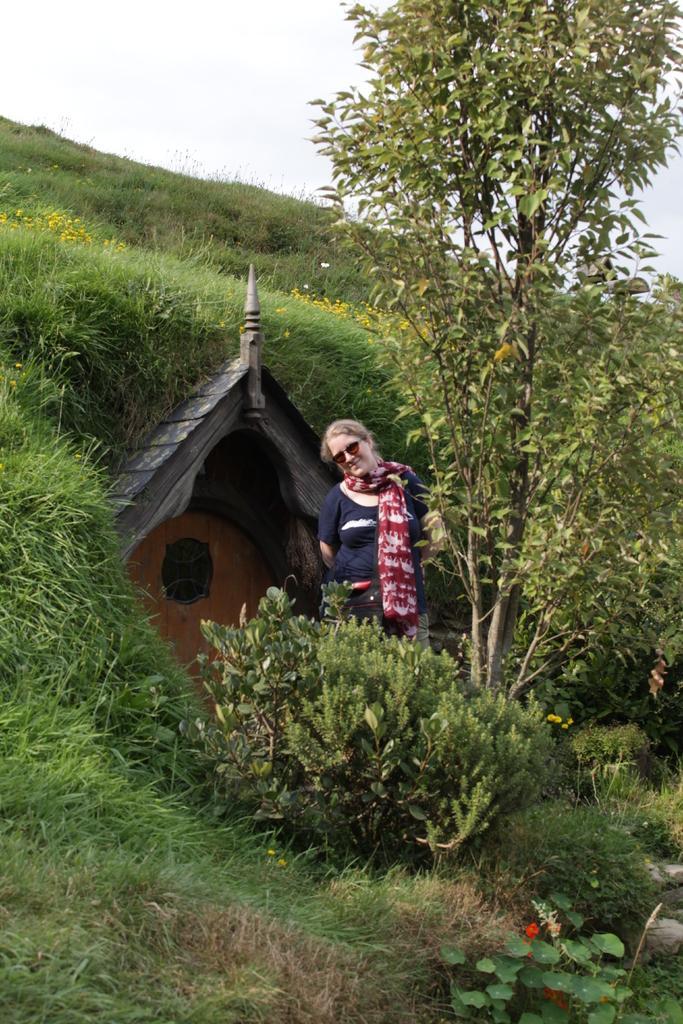Can you describe this image briefly? In this image there is a girl in the middle behind her there is a house. In the background there are trees and grass. At the bottom there are small plants with flowers. At the top there is sky. 